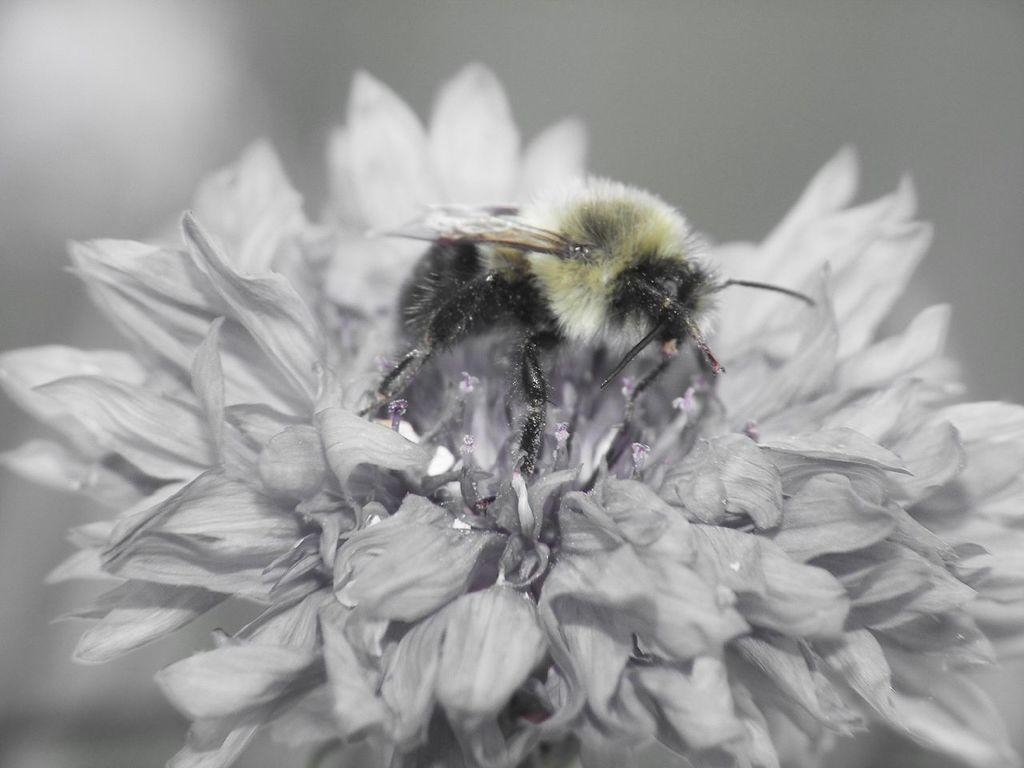What is present in the image? There is an insect in the image. Where is the insect located? The insect is sitting on a flower. What is the color scheme of the image? The image is in black and white color. What type of fuel does the owl use to fly in the image? There is no owl present in the image, so it is not possible to determine what type of fuel it might use. 